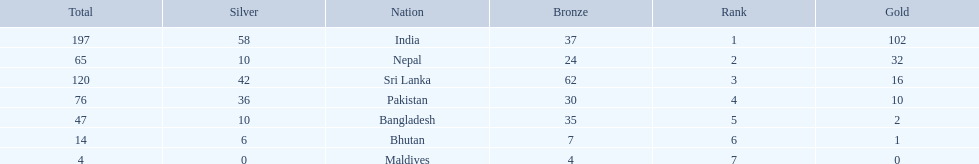What are the total number of bronze medals sri lanka have earned? 62. 